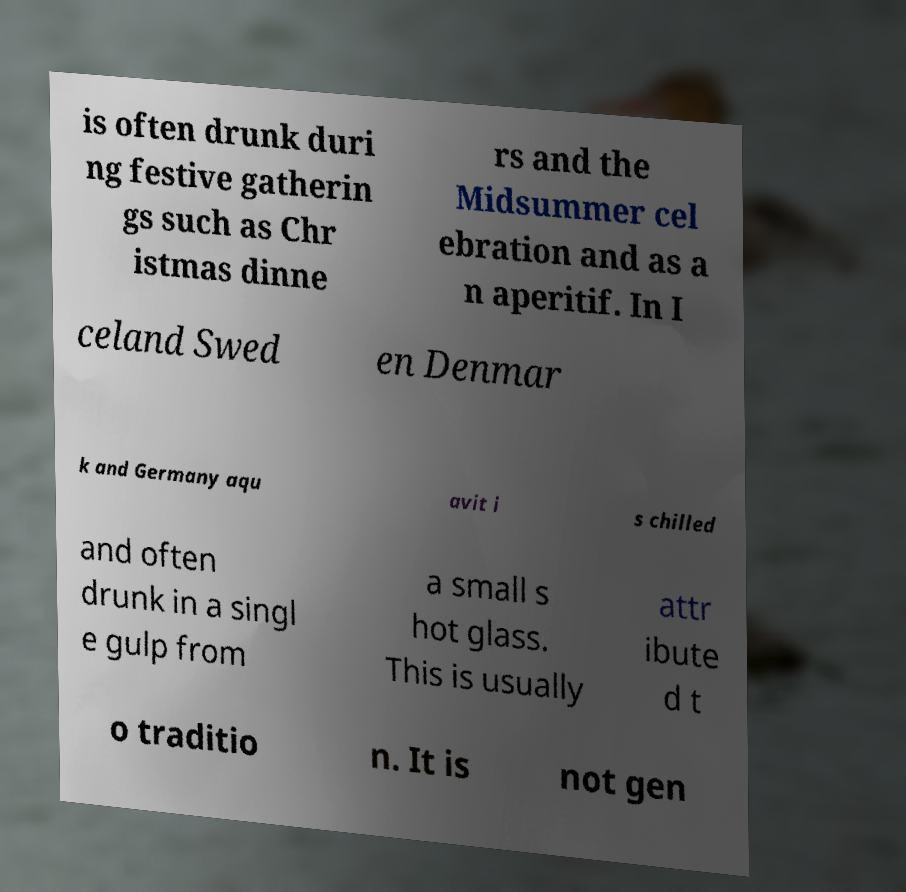Please identify and transcribe the text found in this image. is often drunk duri ng festive gatherin gs such as Chr istmas dinne rs and the Midsummer cel ebration and as a n aperitif. In I celand Swed en Denmar k and Germany aqu avit i s chilled and often drunk in a singl e gulp from a small s hot glass. This is usually attr ibute d t o traditio n. It is not gen 